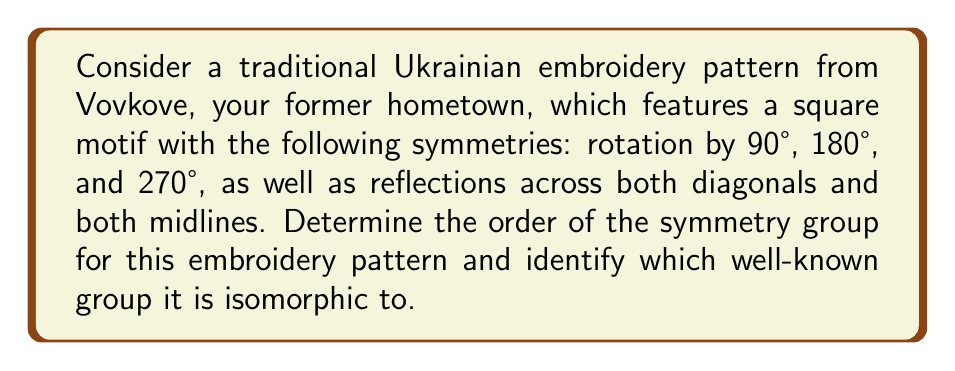Could you help me with this problem? Let's approach this step-by-step:

1) First, let's identify all the symmetries of the pattern:
   - Identity (no change)
   - Rotations: 90°, 180°, 270°
   - Reflections: 2 diagonal reflections, 2 midline reflections

2) Count the total number of symmetries:
   1 (identity) + 3 (rotations) + 4 (reflections) = 8 symmetries

3) The order of the symmetry group is the number of elements, which is 8.

4) To identify which group this is isomorphic to, let's consider the properties:
   - It has 8 elements
   - It includes rotations and reflections
   - The rotations form a cyclic subgroup of order 4

5) These properties match the dihedral group of order 8, denoted as $D_4$ or $D_8$ (depending on notation convention).

6) The dihedral group $D_4$ can be generated by two elements:
   $r$ (90° rotation) and $f$ (reflection)
   
   It has the presentation: $D_4 = \langle r, f | r^4 = f^2 = 1, frf = r^{-1} \rangle$

7) We can verify that this matches our embroidery pattern:
   - $r^4 = 1$ (four 90° rotations return to identity)
   - $f^2 = 1$ (two reflections return to identity)
   - $frf = r^{-1}$ (reflection followed by rotation followed by reflection is equivalent to rotation in the opposite direction)

Therefore, the symmetry group of the embroidery pattern is isomorphic to the dihedral group $D_4$.
Answer: The order of the symmetry group is 8, and it is isomorphic to the dihedral group $D_4$. 